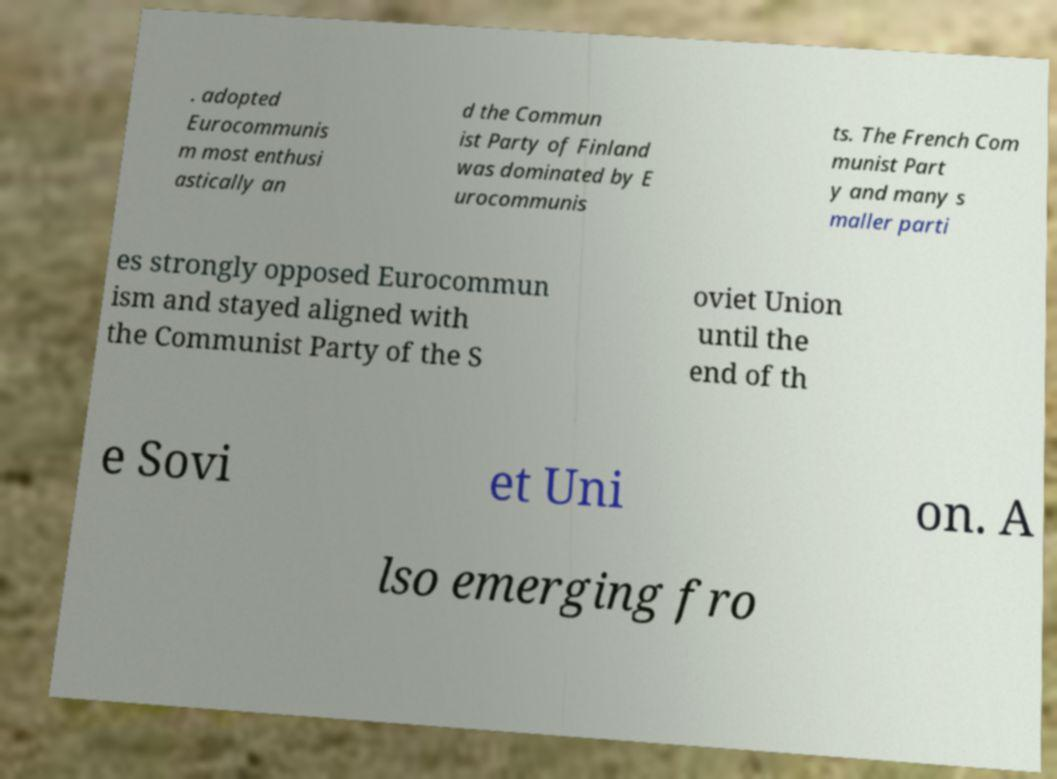Please identify and transcribe the text found in this image. . adopted Eurocommunis m most enthusi astically an d the Commun ist Party of Finland was dominated by E urocommunis ts. The French Com munist Part y and many s maller parti es strongly opposed Eurocommun ism and stayed aligned with the Communist Party of the S oviet Union until the end of th e Sovi et Uni on. A lso emerging fro 